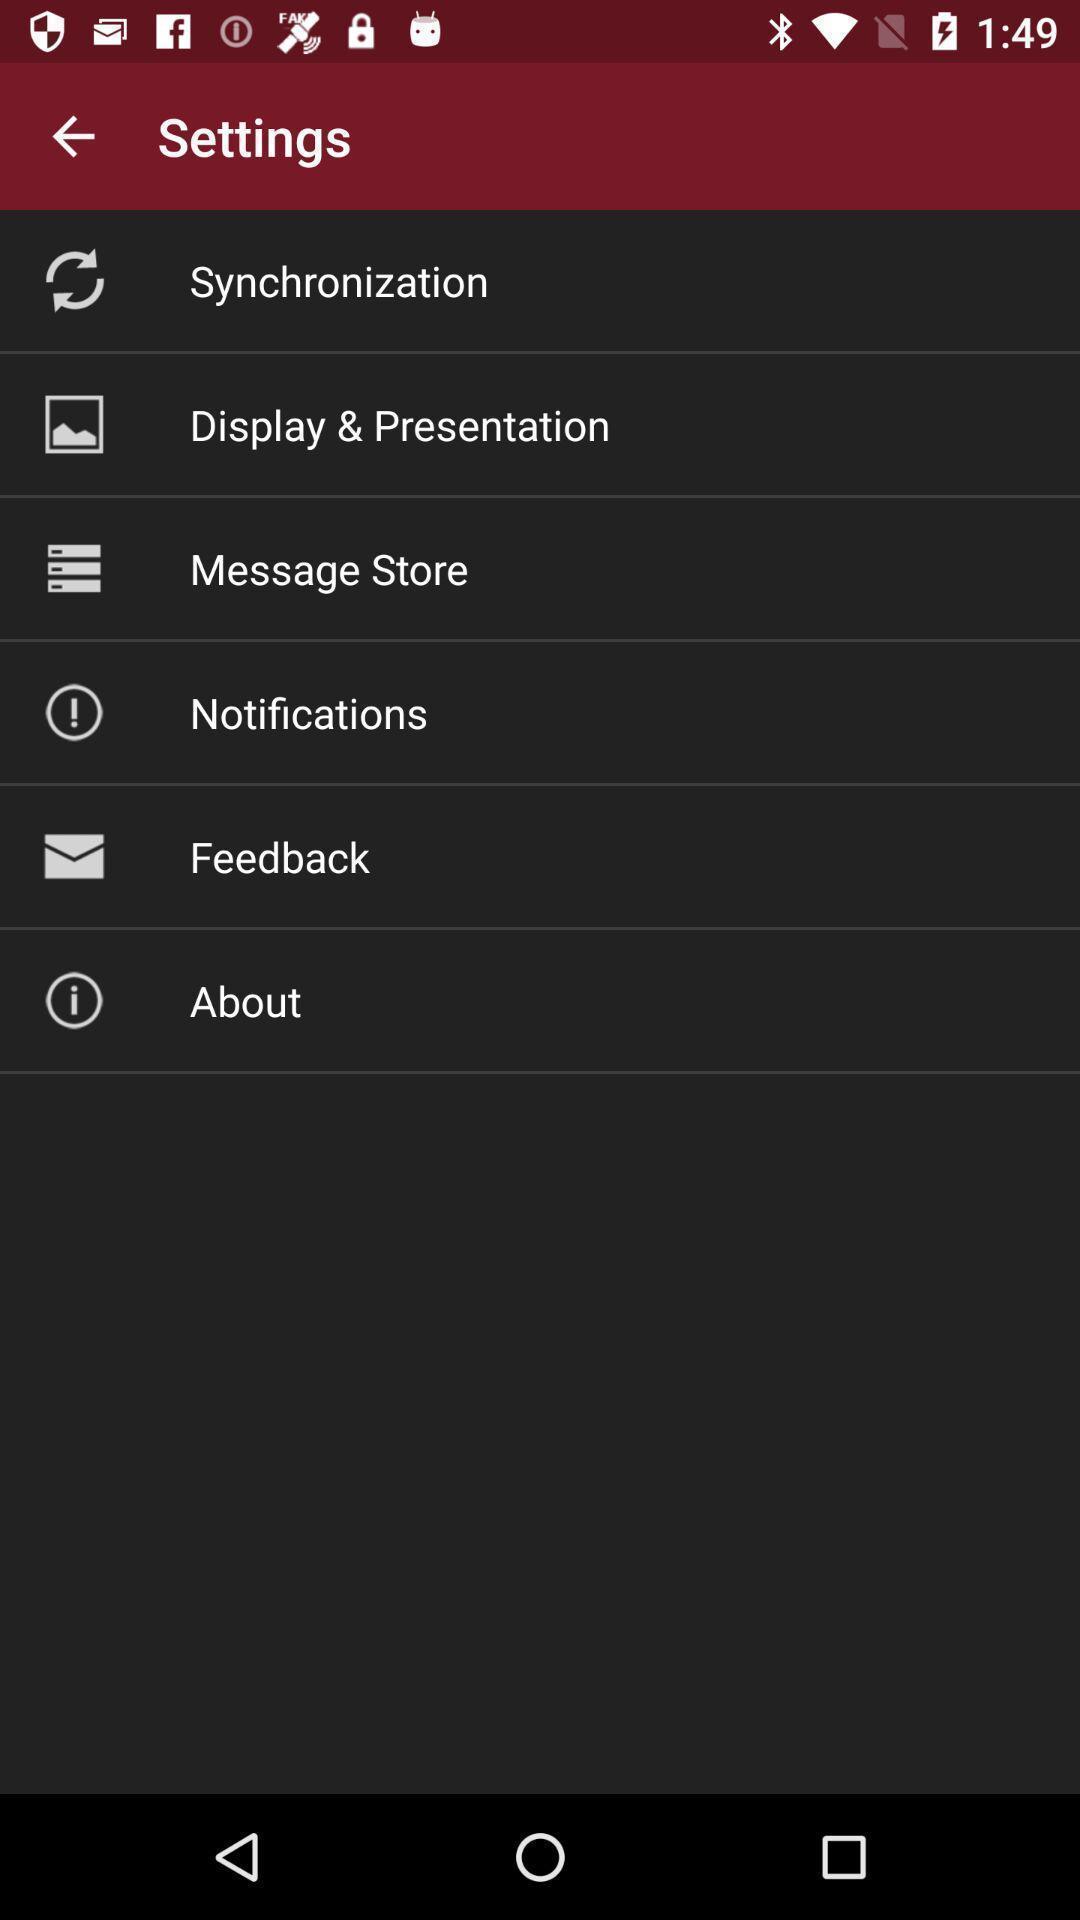Describe the visual elements of this screenshot. Screen showing settings page. 